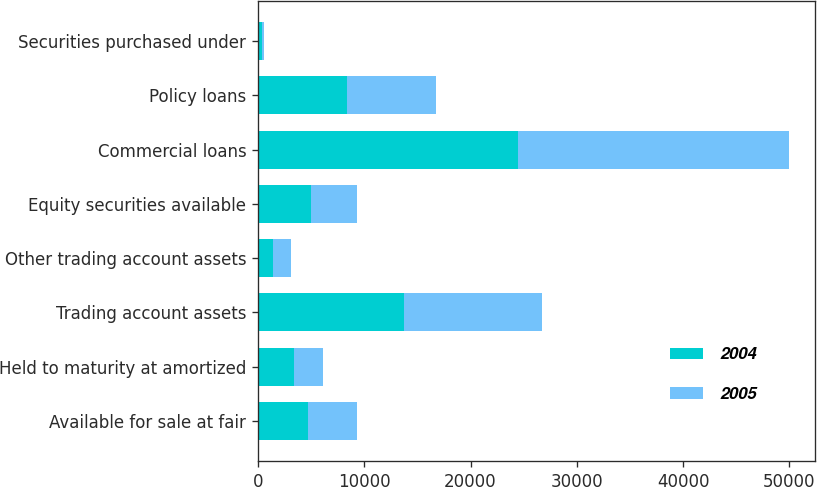Convert chart. <chart><loc_0><loc_0><loc_500><loc_500><stacked_bar_chart><ecel><fcel>Available for sale at fair<fcel>Held to maturity at amortized<fcel>Trading account assets<fcel>Other trading account assets<fcel>Equity securities available<fcel>Commercial loans<fcel>Policy loans<fcel>Securities purchased under<nl><fcel>2004<fcel>4668<fcel>3362<fcel>13781<fcel>1443<fcel>5011<fcel>24441<fcel>8370<fcel>413<nl><fcel>2005<fcel>4668<fcel>2747<fcel>12964<fcel>1613<fcel>4325<fcel>25488<fcel>8373<fcel>127<nl></chart> 